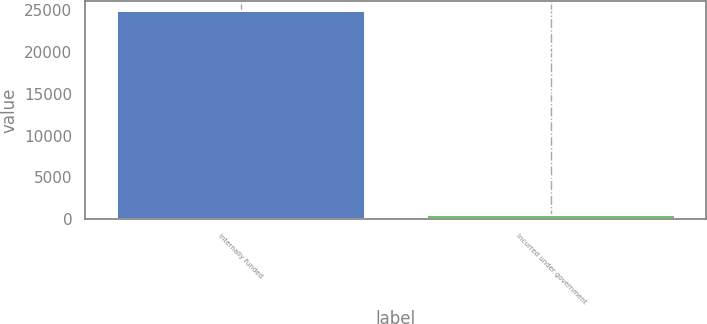Convert chart to OTSL. <chart><loc_0><loc_0><loc_500><loc_500><bar_chart><fcel>Internally funded<fcel>Incurred under government<nl><fcel>24849<fcel>479<nl></chart> 